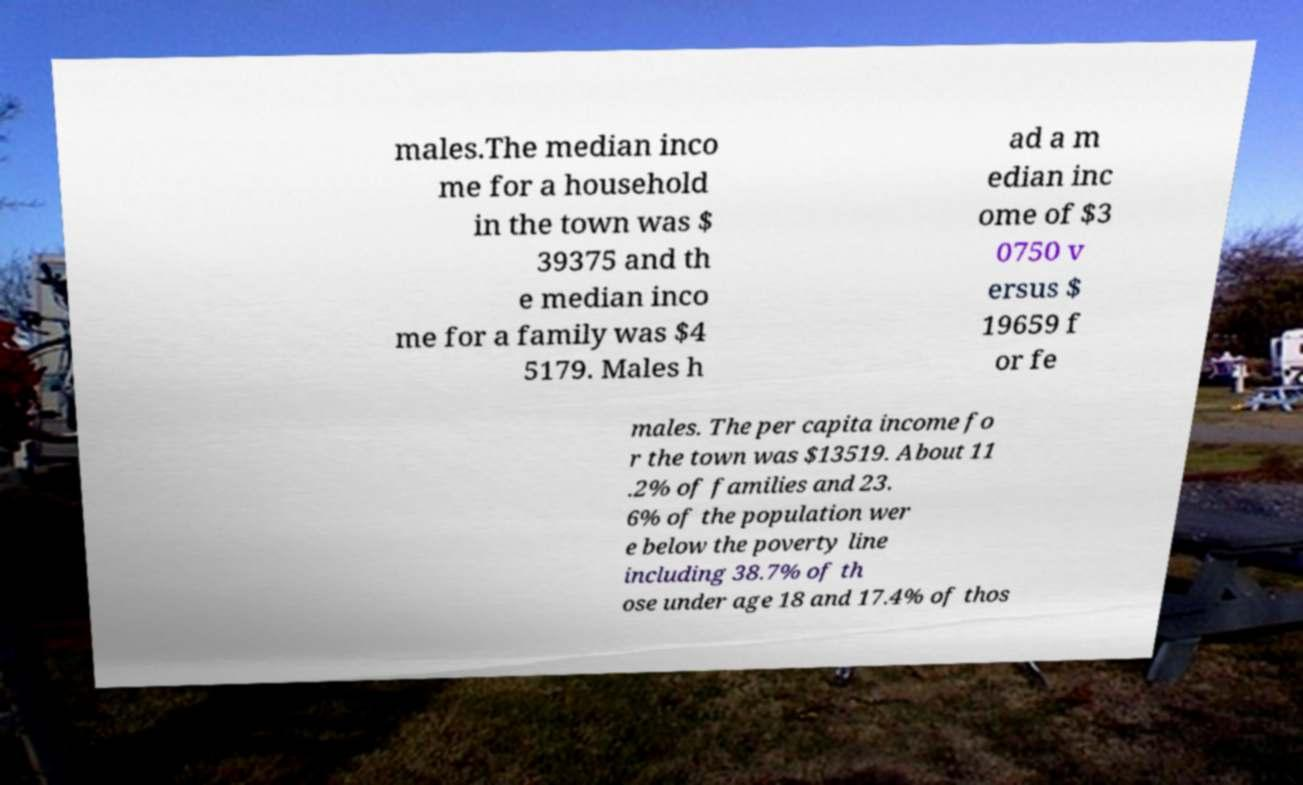Can you accurately transcribe the text from the provided image for me? males.The median inco me for a household in the town was $ 39375 and th e median inco me for a family was $4 5179. Males h ad a m edian inc ome of $3 0750 v ersus $ 19659 f or fe males. The per capita income fo r the town was $13519. About 11 .2% of families and 23. 6% of the population wer e below the poverty line including 38.7% of th ose under age 18 and 17.4% of thos 